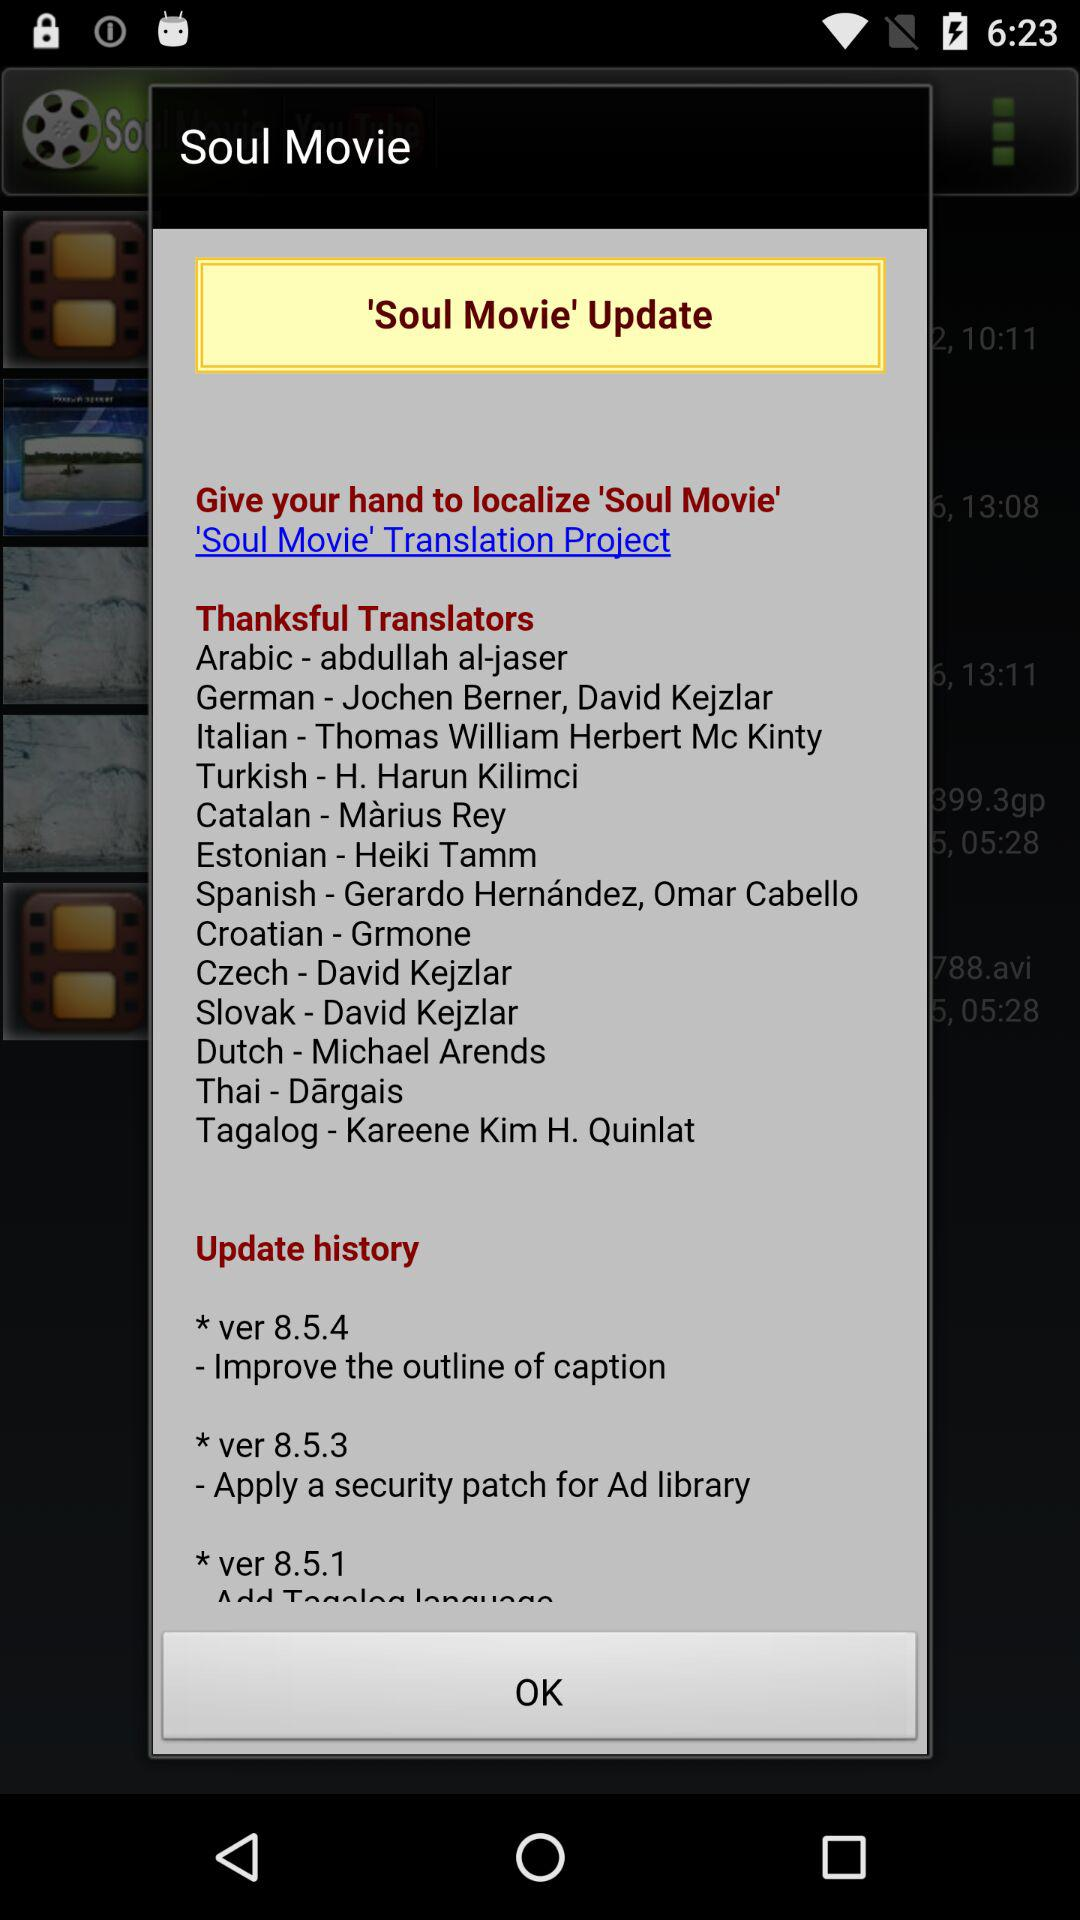What are the Italian translators' names? The name of the Italian translator is Thomas William Herbert Mc Kinty. 